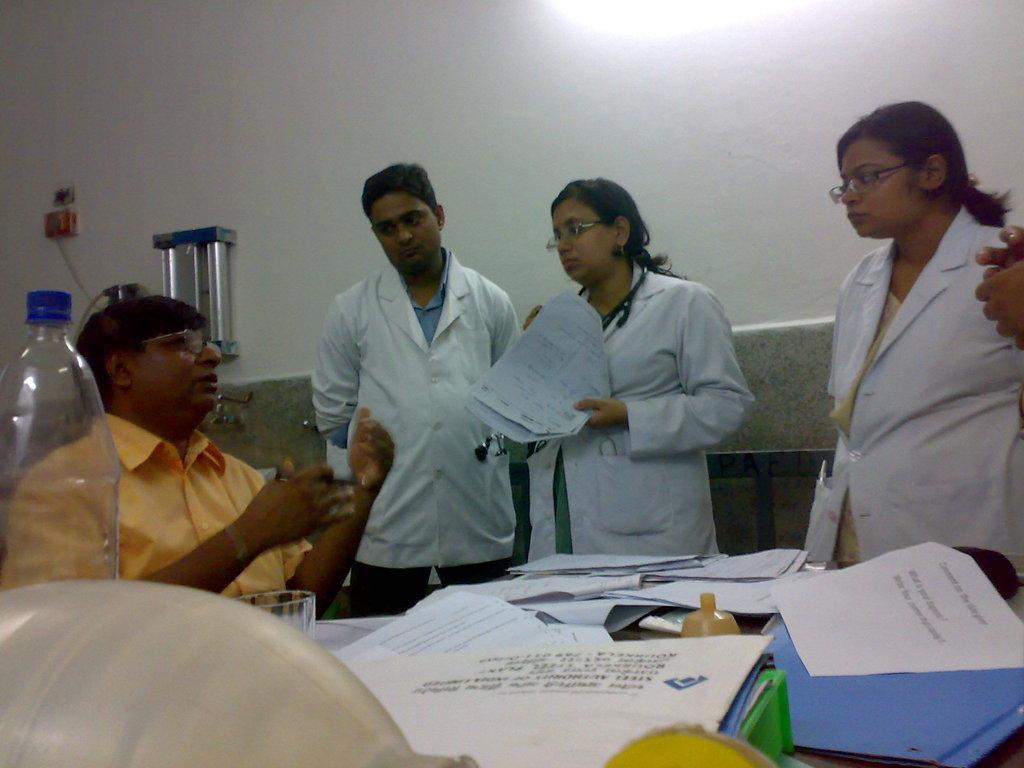Can you describe this image briefly? In this image there are group of person standing and sitting. The woman in the center is standing and holding a paper in her hand. In the front on the table there are paper, glass, bottle. In the background there is a wall and a water filter attached to it. 